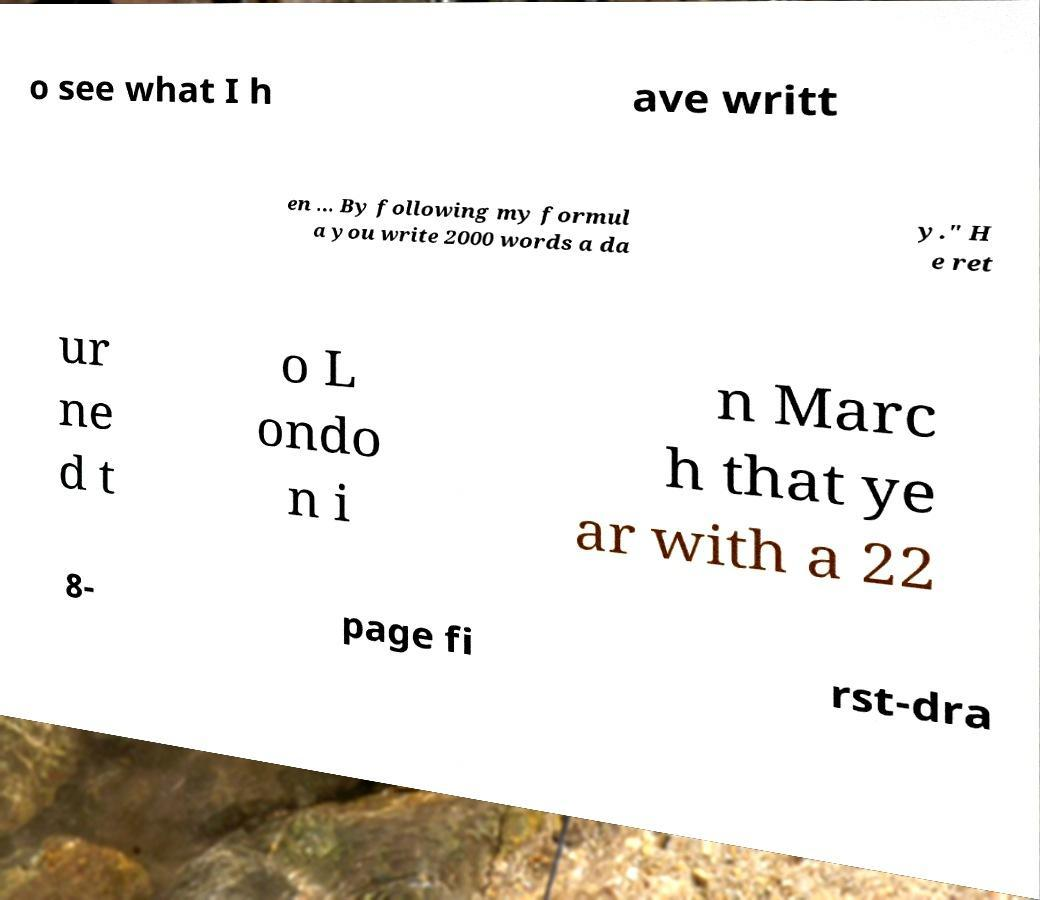What messages or text are displayed in this image? I need them in a readable, typed format. o see what I h ave writt en ... By following my formul a you write 2000 words a da y." H e ret ur ne d t o L ondo n i n Marc h that ye ar with a 22 8- page fi rst-dra 